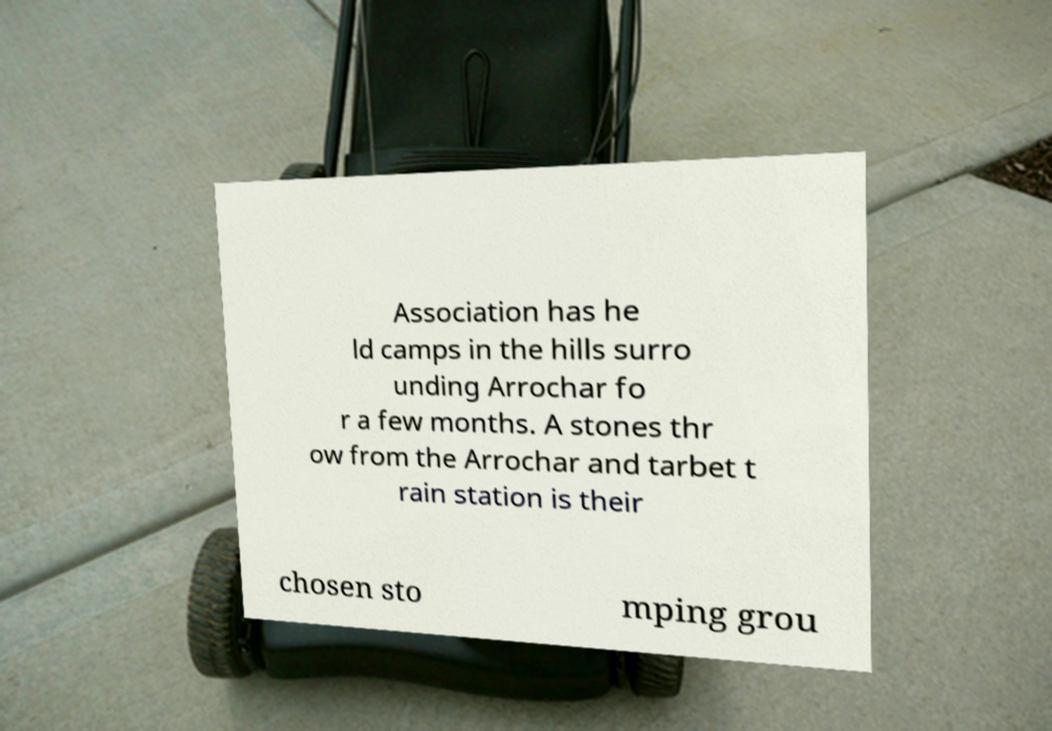Please identify and transcribe the text found in this image. Association has he ld camps in the hills surro unding Arrochar fo r a few months. A stones thr ow from the Arrochar and tarbet t rain station is their chosen sto mping grou 